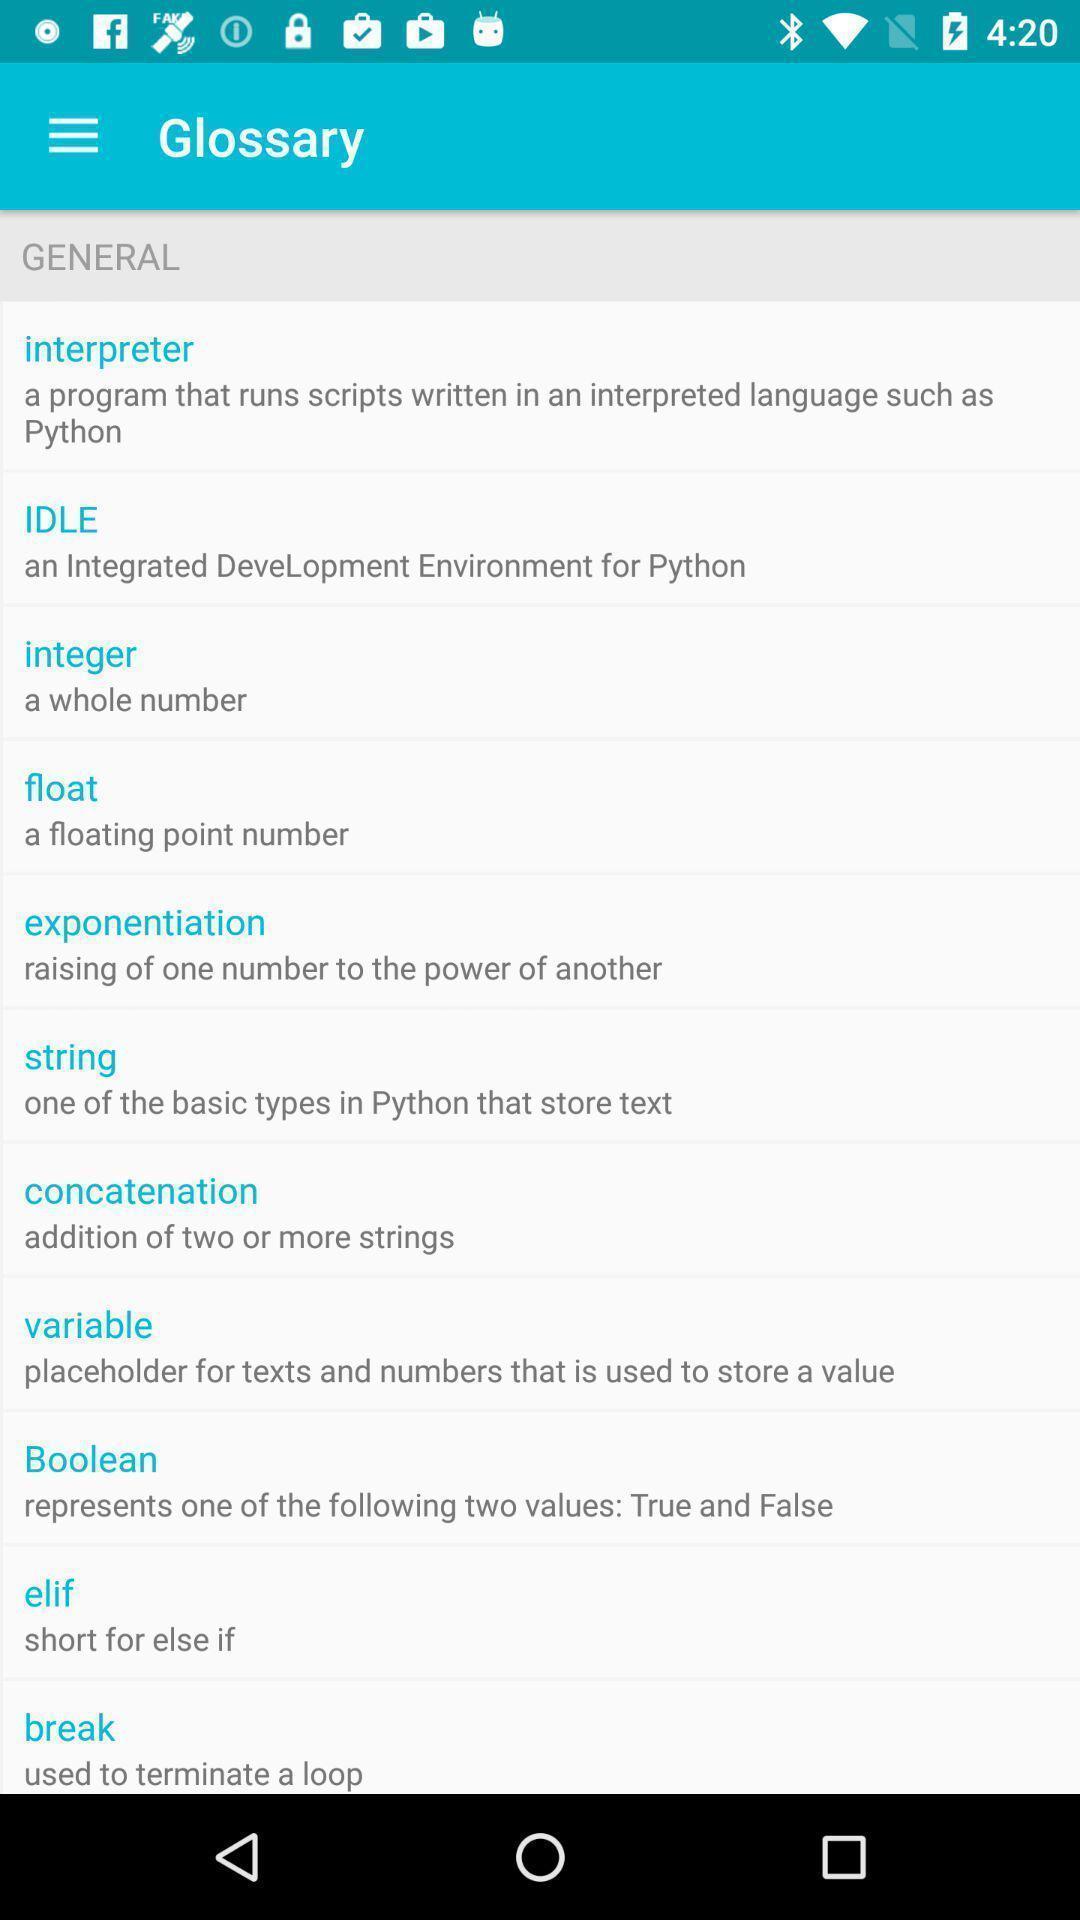Describe this image in words. Screen displaying a list of general options. 